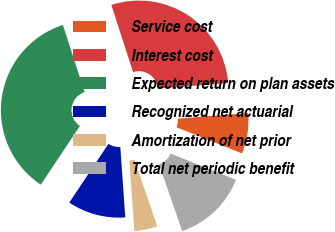Convert chart. <chart><loc_0><loc_0><loc_500><loc_500><pie_chart><fcel>Service cost<fcel>Interest cost<fcel>Expected return on plan assets<fcel>Recognized net actuarial<fcel>Amortization of net prior<fcel>Total net periodic benefit<nl><fcel>7.33%<fcel>28.71%<fcel>35.67%<fcel>10.48%<fcel>4.18%<fcel>13.63%<nl></chart> 